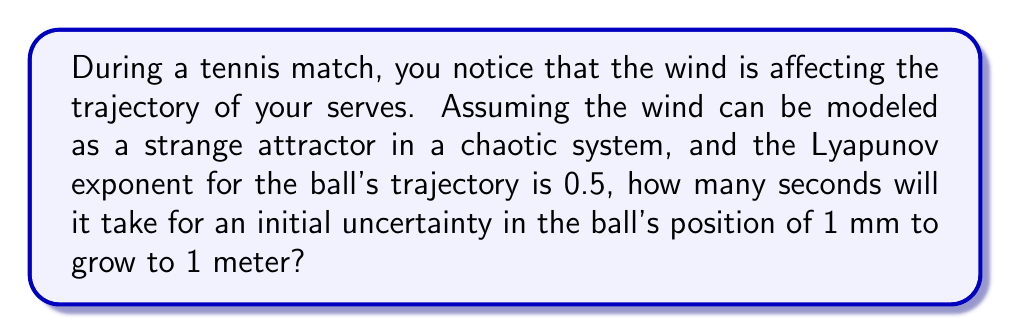Could you help me with this problem? To solve this problem, we'll use concepts from chaos theory and the properties of strange attractors. The key here is understanding how the Lyapunov exponent relates to the growth of uncertainty in a chaotic system.

Step 1: Understand the Lyapunov exponent
The Lyapunov exponent (λ) measures the rate at which nearby trajectories in a dynamical system diverge. In this case, λ = 0.5.

Step 2: Recall the formula for uncertainty growth
The growth of uncertainty in a chaotic system is given by:

$$ d(t) = d_0 e^{\lambda t} $$

Where:
$d(t)$ is the uncertainty at time $t$
$d_0$ is the initial uncertainty
$\lambda$ is the Lyapunov exponent
$t$ is time

Step 3: Set up the equation with given values
Initial uncertainty: $d_0 = 1$ mm = $10^{-3}$ m
Final uncertainty: $d(t) = 1$ m
Lyapunov exponent: $λ = 0.5$

$$ 1 = 10^{-3} e^{0.5t} $$

Step 4: Solve for t
Divide both sides by $10^{-3}$:
$$ 10^3 = e^{0.5t} $$

Take the natural log of both sides:
$$ \ln(10^3) = 0.5t $$

$$ \frac{\ln(10^3)}{0.5} = t $$

$$ t = \frac{\ln(1000)}{0.5} \approx 13.86 \text{ seconds} $$

Therefore, it will take approximately 13.86 seconds for the uncertainty to grow from 1 mm to 1 meter.
Answer: 13.86 seconds 